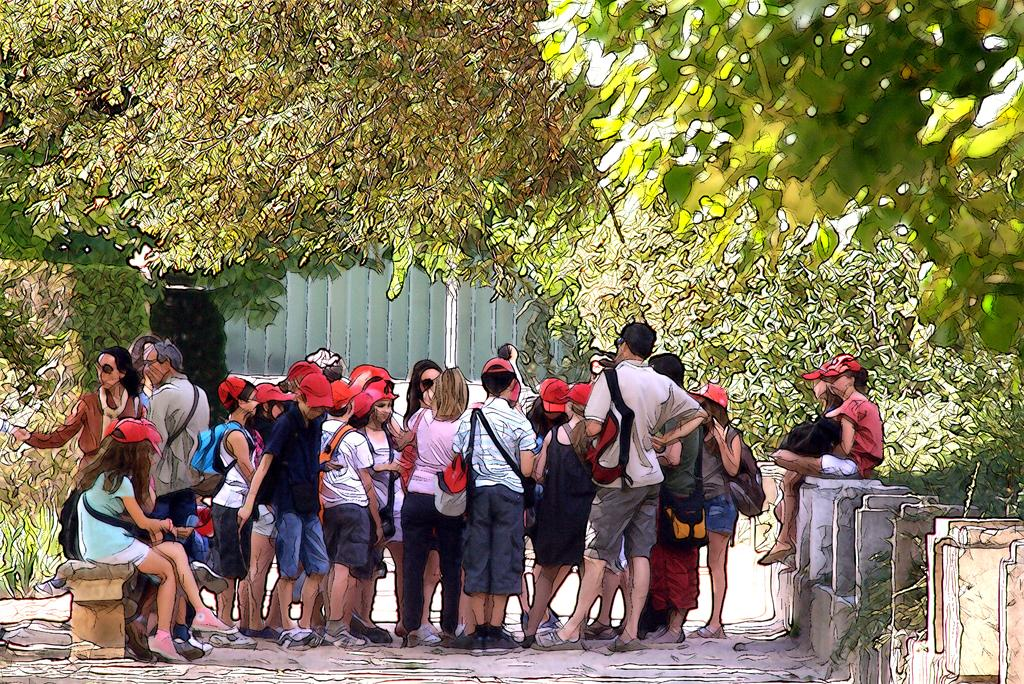What are the people in the image doing? Some people are standing on the road, while others are sitting on benches or walls. Can you describe the background of the image? There are trees and bushes in the background. How are the people positioned in relation to each other? Some people are standing, while others are sitting on benches or walls. What type of powder is being used by the people in the image? There is no powder visible in the image; the people are standing, sitting on benches, or sitting on walls. What kind of machine can be seen in the background of the image? There is no machine present in the image; the background features trees and bushes. 